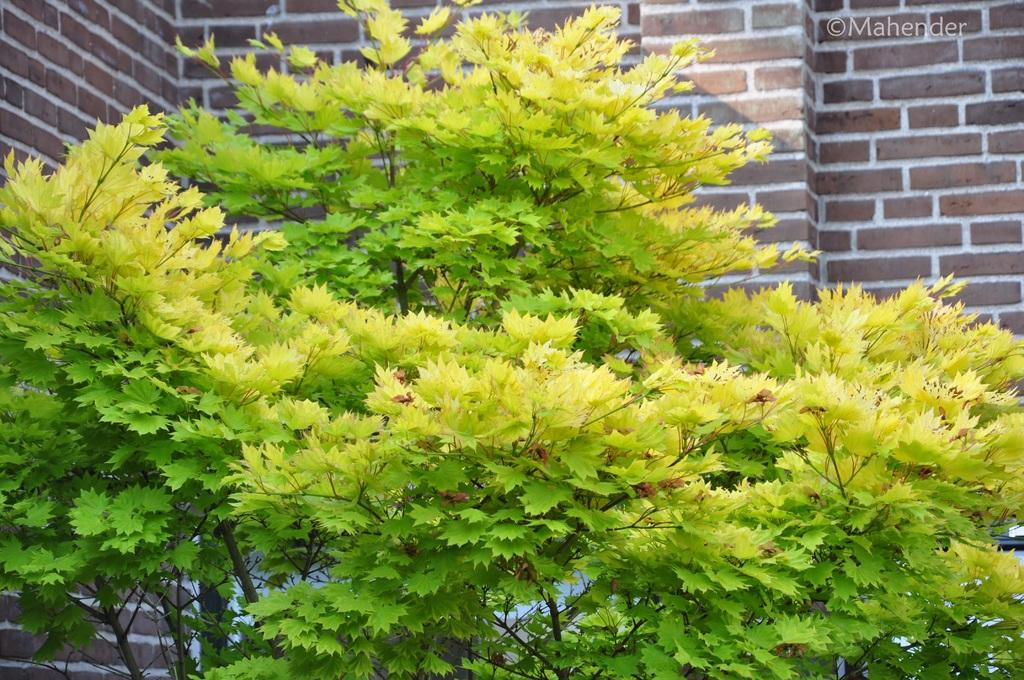What type of plant can be seen in the image? There is a tree in the image. What is the condition of the tree's foliage? The tree has leaves. What can be seen in the background of the image? There is a wall of a building in the background. What material is the wall made of? The wall is made of red bricks. Can you tell me how many women are holding kettles in the image? There are no women or kettles present in the image. 